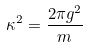Convert formula to latex. <formula><loc_0><loc_0><loc_500><loc_500>\kappa ^ { 2 } = \frac { 2 \pi g ^ { 2 } } { m }</formula> 